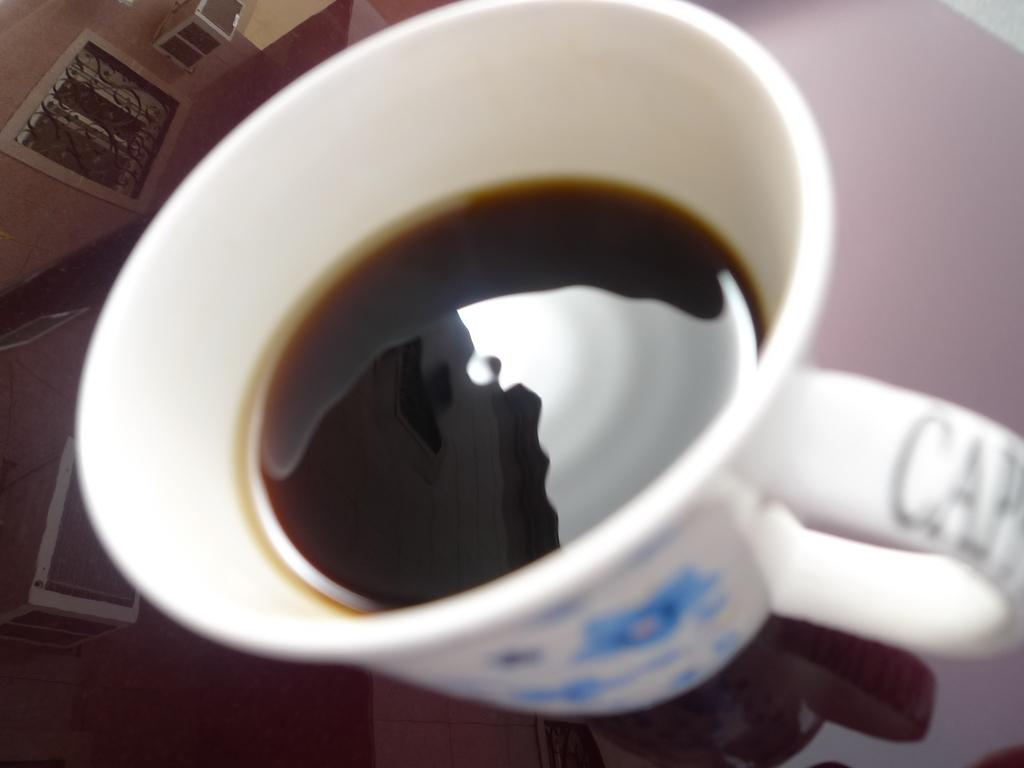What piece of furniture is present in the image? There is a table in the image. What object is placed on the table? There is a coffee cup on the table. How does the leg cast affect the table in the image? There is no leg cast present in the image, as it only features a table and a coffee cup. 